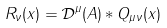<formula> <loc_0><loc_0><loc_500><loc_500>R _ { \nu } ( x ) = \mathcal { D } ^ { \mu } ( A ) * Q _ { \mu \nu } ( x )</formula> 